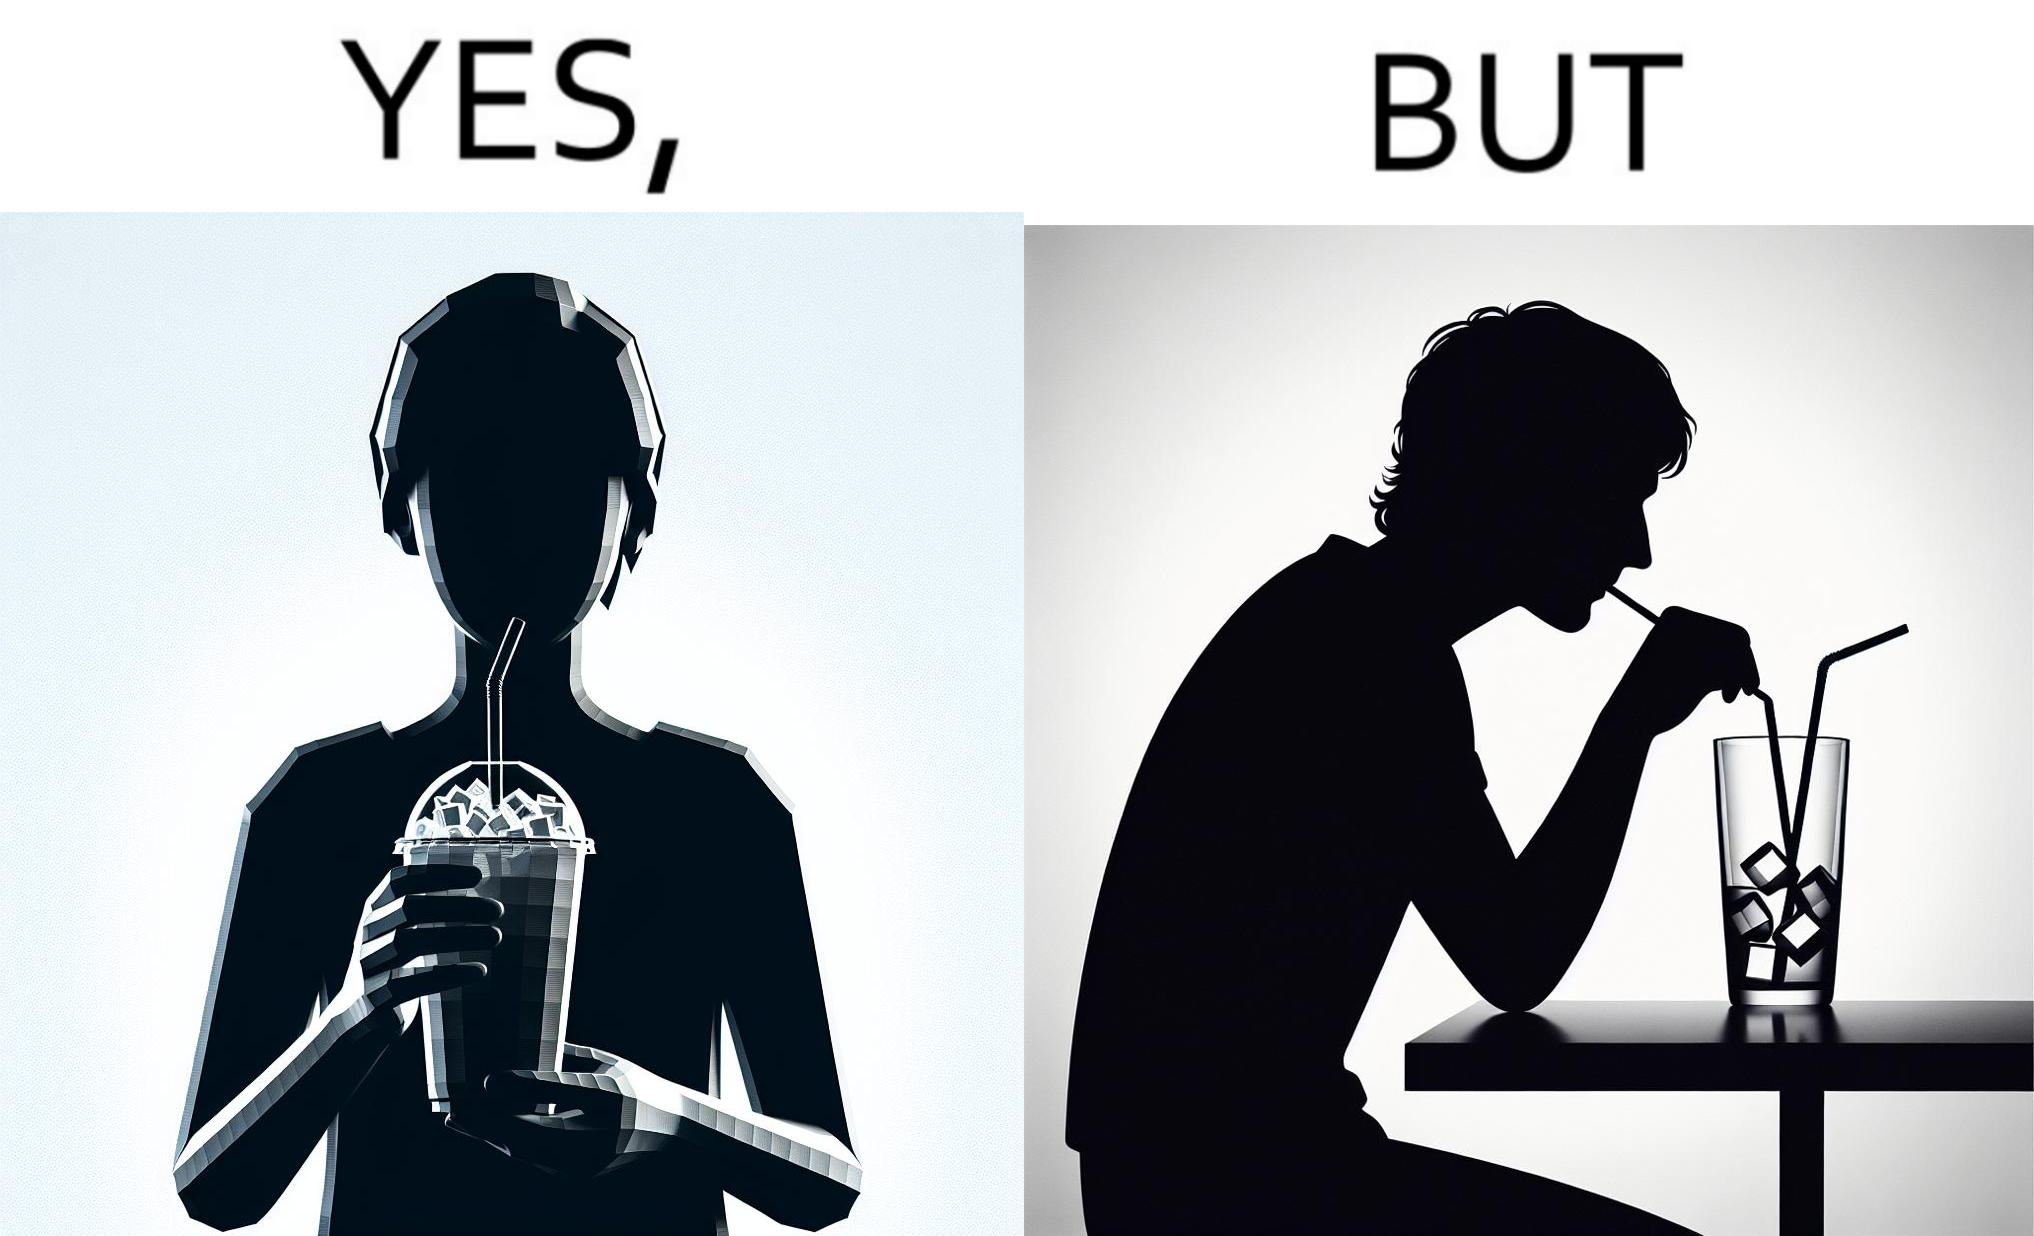Explain why this image is satirical. The image is funny, as the drink seems to be full to begin with, while most of the volume of the drink is occupied by the ice cubes. 